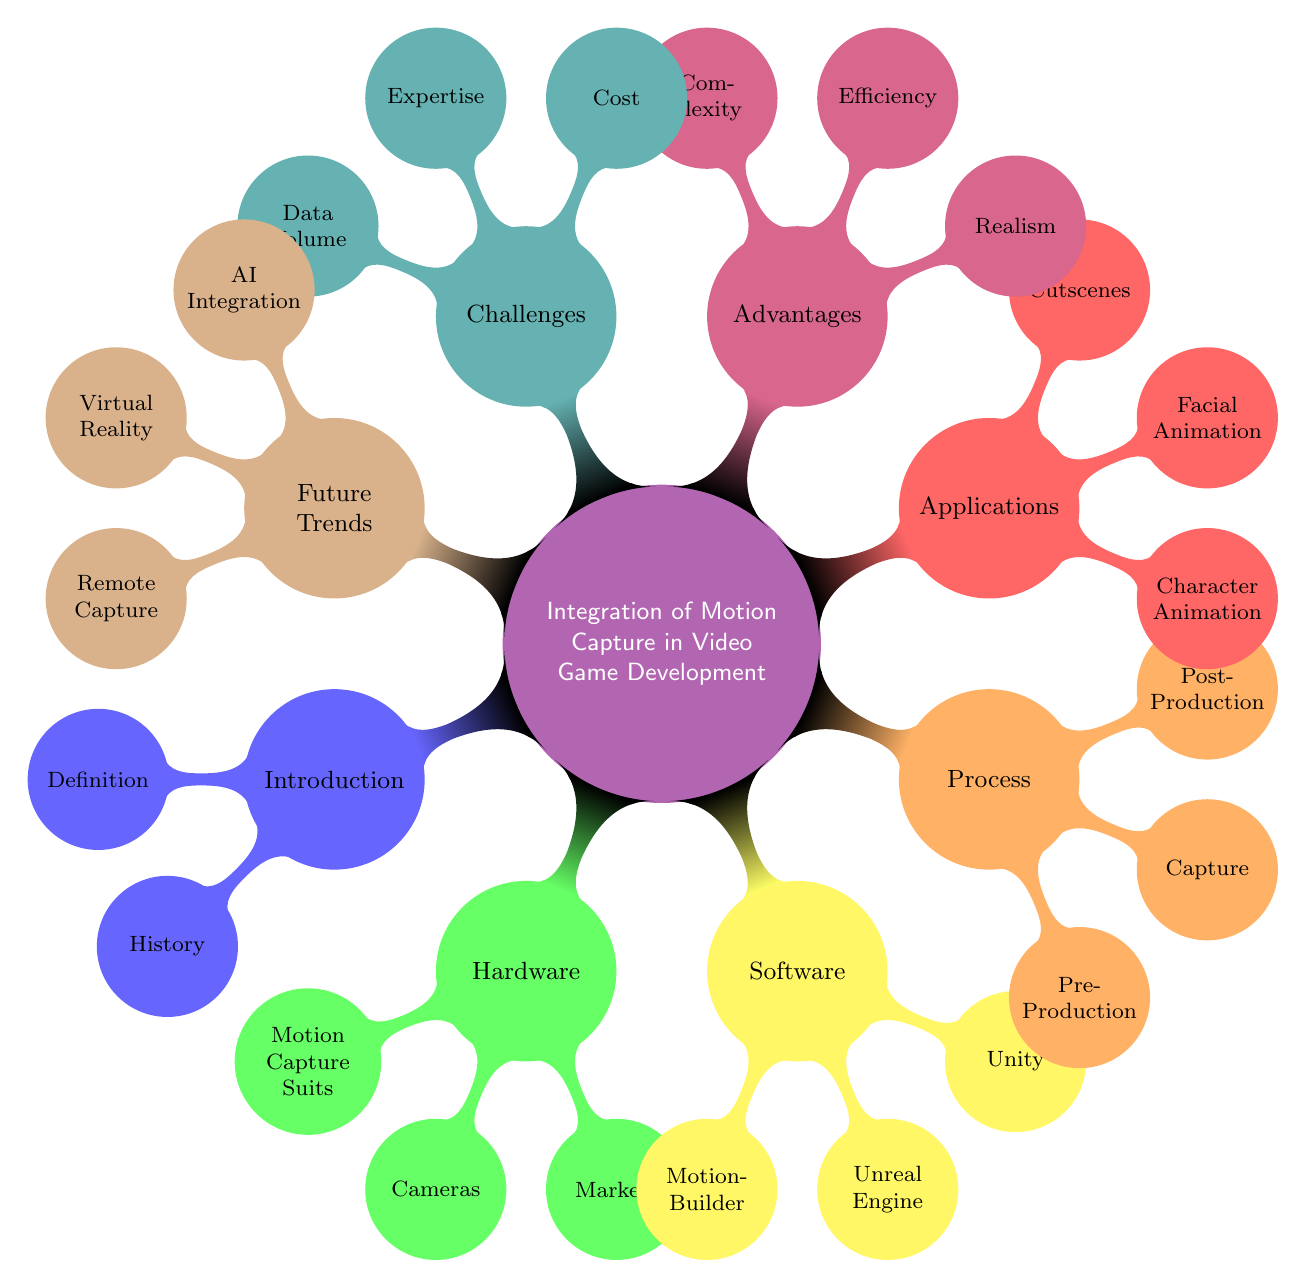What is the main topic of the mind map? The central node of the mind map is labeled "Integration of Motion Capture in Video Game Development," which identifies the core subject being discussed.
Answer: Integration of Motion Capture in Video Game Development How many child nodes does the "Applications" category have? The "Applications" category has three child nodes: Character Animation, Facial Animation, and Cutscenes. This can be counted directly from the diagram.
Answer: 3 What hardware is mentioned for motion capture? The hardware section includes Motion Capture Suits, Cameras, and Markers as listed directly in the diagram.
Answer: Motion Capture Suits, Cameras, Markers What is one advantage of using motion capture technology? Under the "Advantages" category, one listed advantage is "Realism," which enhances the quality of animations in video games.
Answer: Realism Which software is recognized for motion capture data processing? The software section names "MotionBuilder" as a leading software specifically used for processing motion capture data. This can be referenced directly from the software node.
Answer: MotionBuilder What phase comes after "Capture" in the motion capture process? Following the "Capture" phase in the process, "Post-Production" is the next phase listed in the mind map, indicating the sequence of steps in motion capture development.
Answer: Post-Production Which two future trends are associated with motion capture technology? The future trends section includes "AI Integration" and "Virtual Reality," which highlight advancements expected in the field of motion capture in the coming years.
Answer: AI Integration, Virtual Reality How many challenges are listed regarding the integration of motion capture? The challenges section contains three child nodes: Cost, Expertise, and Data Volume, which can be counted to provide the total number of challenges mentioned in the diagram.
Answer: 3 